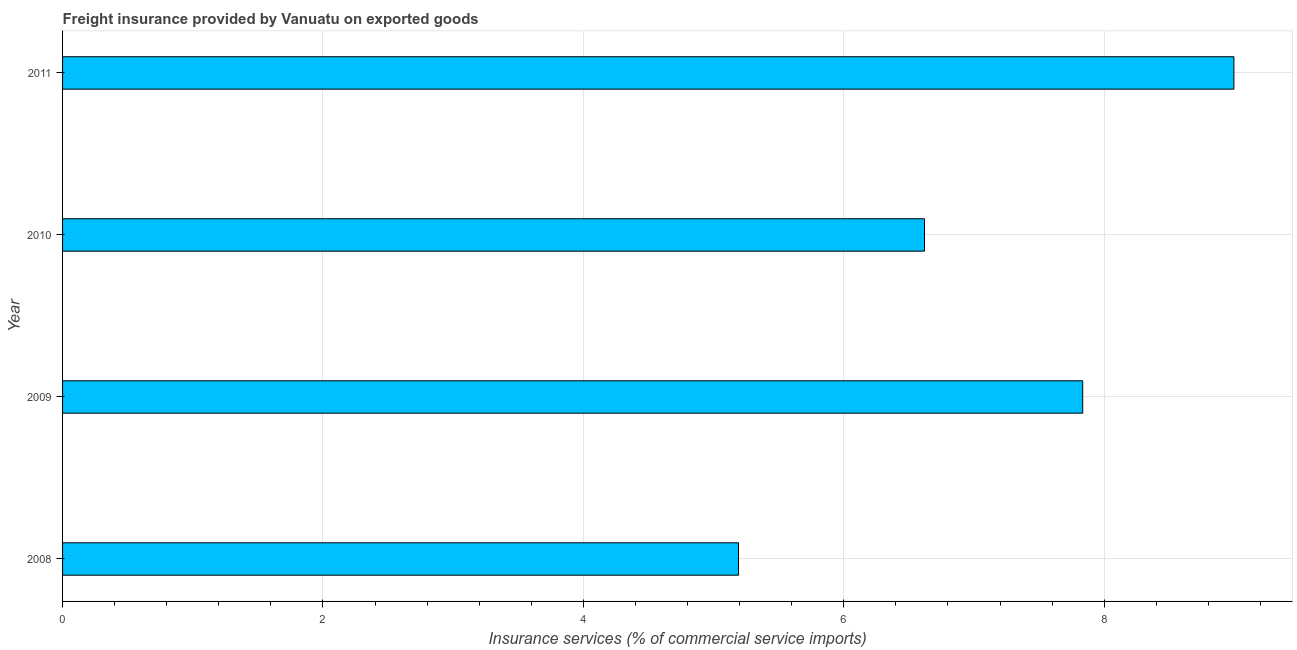Does the graph contain any zero values?
Offer a very short reply. No. What is the title of the graph?
Make the answer very short. Freight insurance provided by Vanuatu on exported goods . What is the label or title of the X-axis?
Offer a very short reply. Insurance services (% of commercial service imports). What is the freight insurance in 2011?
Give a very brief answer. 9. Across all years, what is the maximum freight insurance?
Provide a short and direct response. 9. Across all years, what is the minimum freight insurance?
Give a very brief answer. 5.19. In which year was the freight insurance maximum?
Provide a succinct answer. 2011. In which year was the freight insurance minimum?
Your response must be concise. 2008. What is the sum of the freight insurance?
Your answer should be compact. 28.64. What is the difference between the freight insurance in 2008 and 2011?
Provide a succinct answer. -3.81. What is the average freight insurance per year?
Your answer should be compact. 7.16. What is the median freight insurance?
Ensure brevity in your answer.  7.23. In how many years, is the freight insurance greater than 2.8 %?
Offer a very short reply. 4. Do a majority of the years between 2009 and 2010 (inclusive) have freight insurance greater than 0.4 %?
Ensure brevity in your answer.  Yes. What is the ratio of the freight insurance in 2008 to that in 2009?
Ensure brevity in your answer.  0.66. Is the freight insurance in 2008 less than that in 2011?
Offer a very short reply. Yes. Is the difference between the freight insurance in 2010 and 2011 greater than the difference between any two years?
Make the answer very short. No. What is the difference between the highest and the second highest freight insurance?
Offer a very short reply. 1.16. What is the difference between the highest and the lowest freight insurance?
Your answer should be compact. 3.8. In how many years, is the freight insurance greater than the average freight insurance taken over all years?
Make the answer very short. 2. How many years are there in the graph?
Offer a terse response. 4. What is the difference between two consecutive major ticks on the X-axis?
Your answer should be compact. 2. Are the values on the major ticks of X-axis written in scientific E-notation?
Make the answer very short. No. What is the Insurance services (% of commercial service imports) in 2008?
Ensure brevity in your answer.  5.19. What is the Insurance services (% of commercial service imports) in 2009?
Your answer should be compact. 7.84. What is the Insurance services (% of commercial service imports) of 2010?
Your answer should be compact. 6.62. What is the Insurance services (% of commercial service imports) of 2011?
Keep it short and to the point. 9. What is the difference between the Insurance services (% of commercial service imports) in 2008 and 2009?
Keep it short and to the point. -2.64. What is the difference between the Insurance services (% of commercial service imports) in 2008 and 2010?
Your response must be concise. -1.43. What is the difference between the Insurance services (% of commercial service imports) in 2008 and 2011?
Provide a succinct answer. -3.8. What is the difference between the Insurance services (% of commercial service imports) in 2009 and 2010?
Give a very brief answer. 1.22. What is the difference between the Insurance services (% of commercial service imports) in 2009 and 2011?
Ensure brevity in your answer.  -1.16. What is the difference between the Insurance services (% of commercial service imports) in 2010 and 2011?
Keep it short and to the point. -2.38. What is the ratio of the Insurance services (% of commercial service imports) in 2008 to that in 2009?
Offer a very short reply. 0.66. What is the ratio of the Insurance services (% of commercial service imports) in 2008 to that in 2010?
Your answer should be very brief. 0.78. What is the ratio of the Insurance services (% of commercial service imports) in 2008 to that in 2011?
Keep it short and to the point. 0.58. What is the ratio of the Insurance services (% of commercial service imports) in 2009 to that in 2010?
Your answer should be compact. 1.18. What is the ratio of the Insurance services (% of commercial service imports) in 2009 to that in 2011?
Offer a terse response. 0.87. What is the ratio of the Insurance services (% of commercial service imports) in 2010 to that in 2011?
Provide a succinct answer. 0.74. 